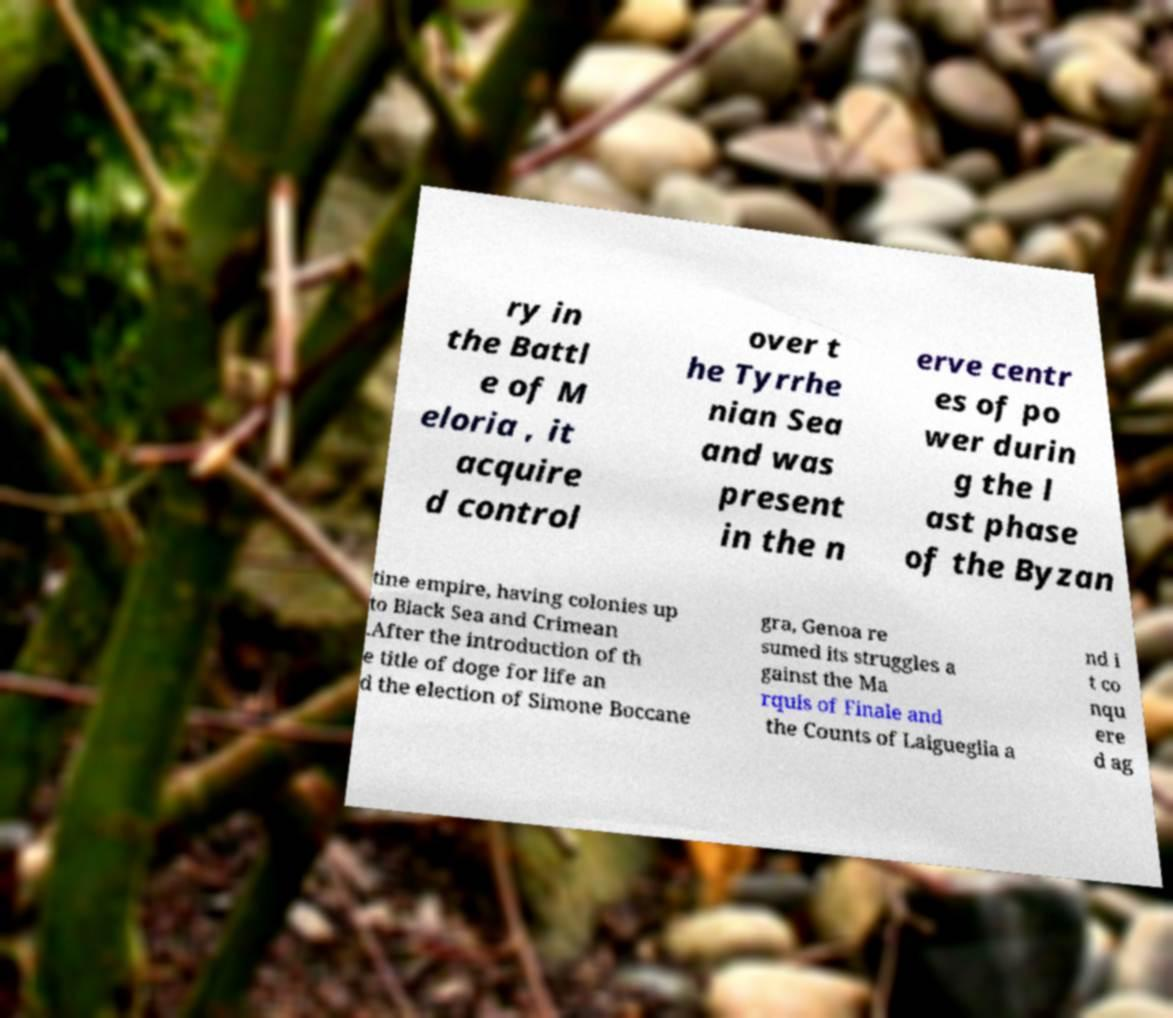Could you assist in decoding the text presented in this image and type it out clearly? ry in the Battl e of M eloria , it acquire d control over t he Tyrrhe nian Sea and was present in the n erve centr es of po wer durin g the l ast phase of the Byzan tine empire, having colonies up to Black Sea and Crimean .After the introduction of th e title of doge for life an d the election of Simone Boccane gra, Genoa re sumed its struggles a gainst the Ma rquis of Finale and the Counts of Laigueglia a nd i t co nqu ere d ag 